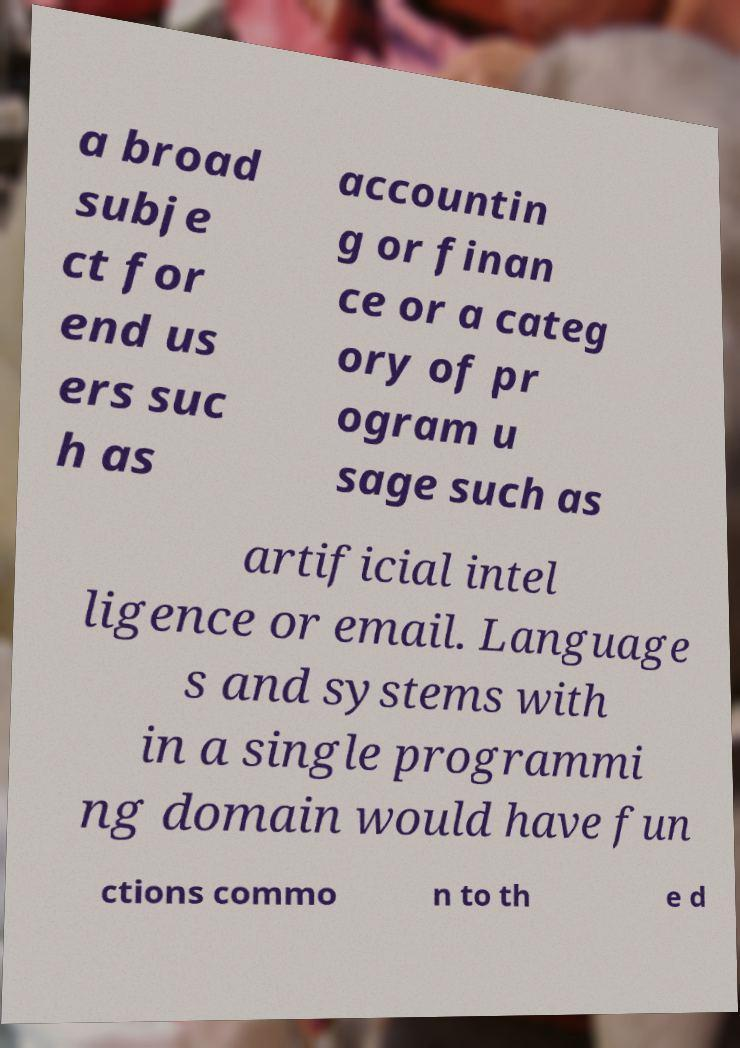For documentation purposes, I need the text within this image transcribed. Could you provide that? a broad subje ct for end us ers suc h as accountin g or finan ce or a categ ory of pr ogram u sage such as artificial intel ligence or email. Language s and systems with in a single programmi ng domain would have fun ctions commo n to th e d 